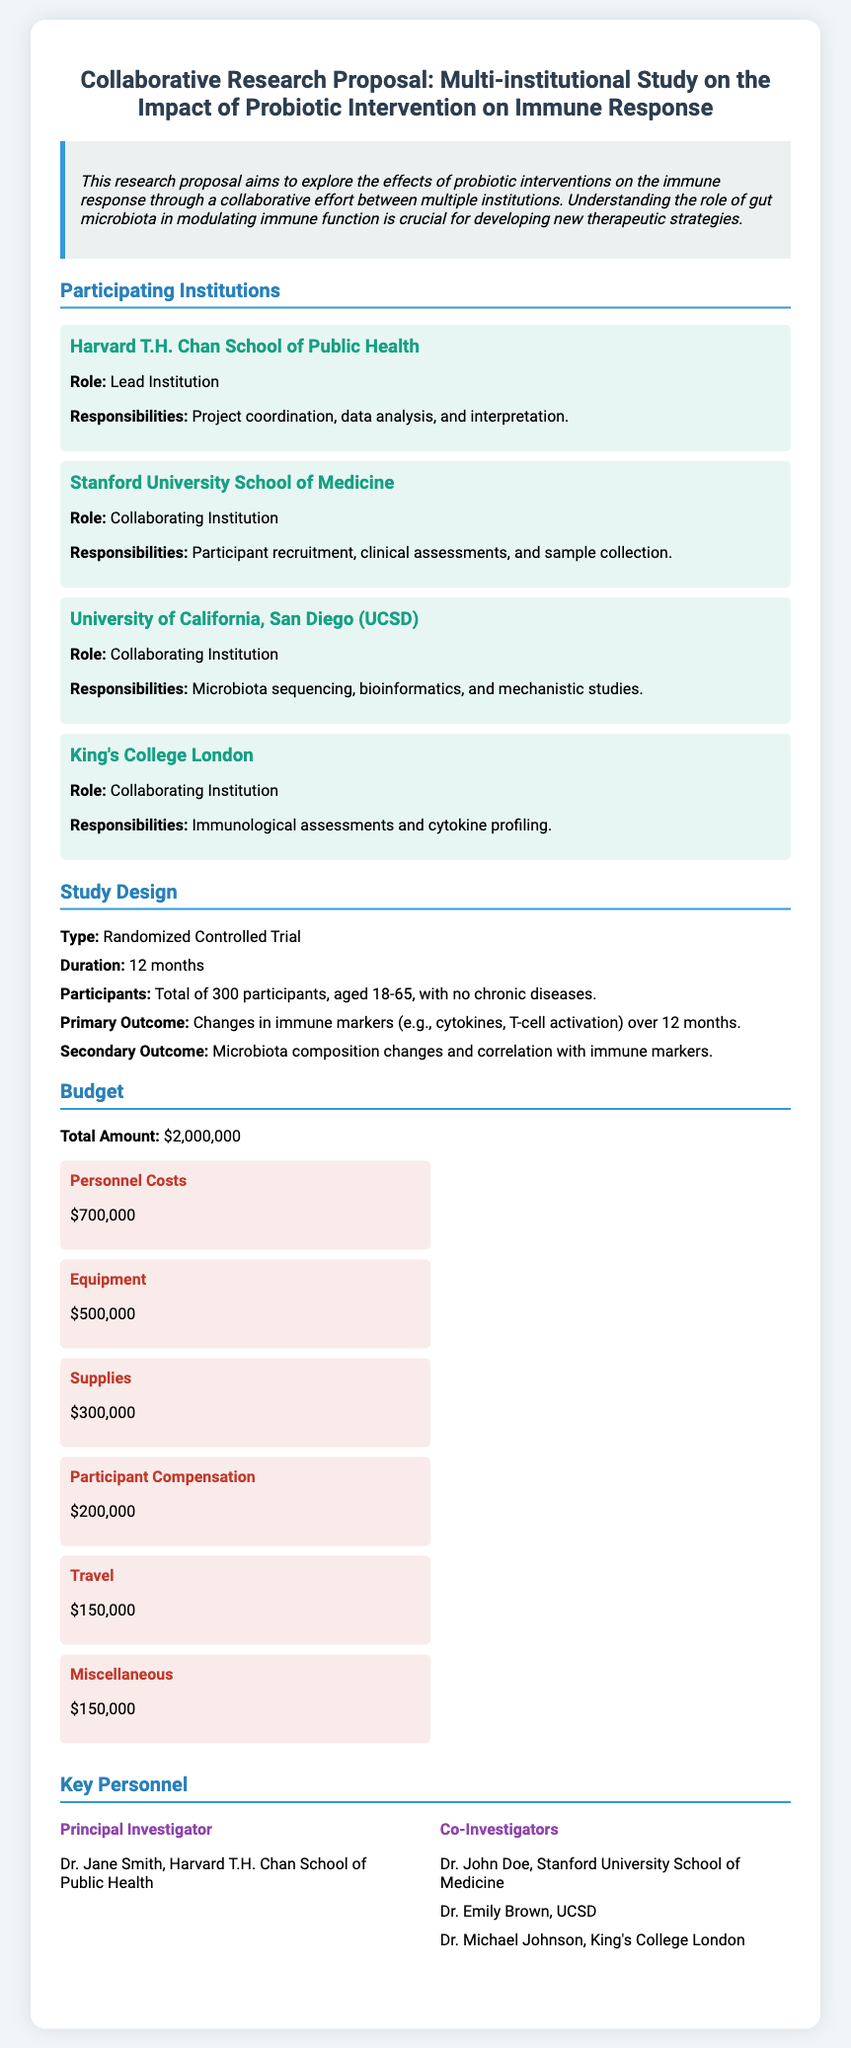What is the lead institution? The document states that the lead institution is responsible for project coordination, data analysis, and interpretation.
Answer: Harvard T.H. Chan School of Public Health What is the primary outcome of the study? The document outlines the primary outcome as changes in immune markers over the 12 months.
Answer: Changes in immune markers What is the total budget for the study? The document specifies the total amount allocated for the research proposal.
Answer: $2,000,000 Which institution is responsible for microbiota sequencing? The responsibilities listed for this institution include microbiota sequencing among other tasks.
Answer: University of California, San Diego (UCSD) Who is the principal investigator? The document names the principal investigator as a key personnel in the research proposal.
Answer: Dr. Jane Smith What is the study duration? The document mentions the duration of the study in months.
Answer: 12 months How many participants are involved in the study? The document provides the total number of participants eligible for the study.
Answer: 300 participants What is one of the secondary outcomes? The document lists secondary outcomes including microbiota composition changes.
Answer: Microbiota composition changes 